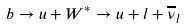Convert formula to latex. <formula><loc_0><loc_0><loc_500><loc_500>b \rightarrow u + W ^ { * } \rightarrow u + l + \overline { \nu } _ { l }</formula> 